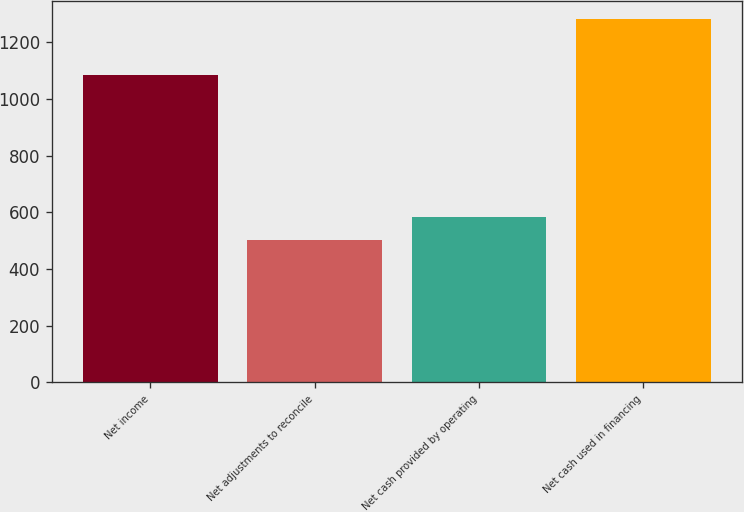Convert chart to OTSL. <chart><loc_0><loc_0><loc_500><loc_500><bar_chart><fcel>Net income<fcel>Net adjustments to reconcile<fcel>Net cash provided by operating<fcel>Net cash used in financing<nl><fcel>1084<fcel>501<fcel>583<fcel>1282<nl></chart> 